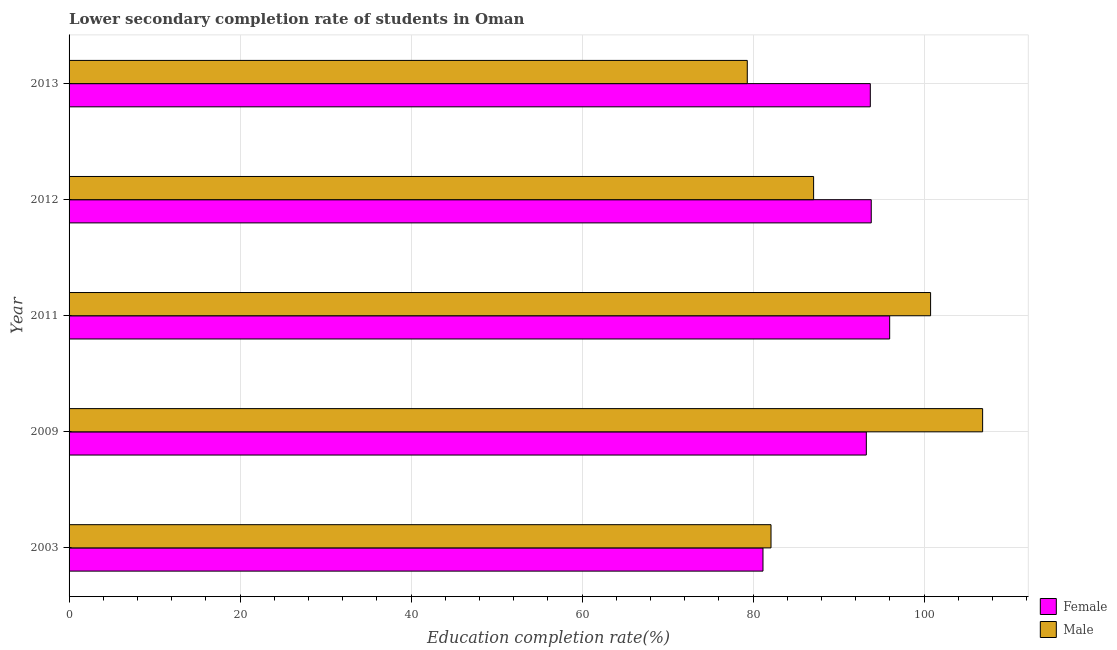How many different coloured bars are there?
Offer a very short reply. 2. How many groups of bars are there?
Your response must be concise. 5. How many bars are there on the 5th tick from the bottom?
Your response must be concise. 2. What is the education completion rate of male students in 2012?
Give a very brief answer. 87.08. Across all years, what is the maximum education completion rate of female students?
Ensure brevity in your answer.  95.97. Across all years, what is the minimum education completion rate of female students?
Your answer should be compact. 81.16. In which year was the education completion rate of male students maximum?
Give a very brief answer. 2009. What is the total education completion rate of male students in the graph?
Offer a very short reply. 456.1. What is the difference between the education completion rate of female students in 2003 and that in 2012?
Offer a terse response. -12.66. What is the difference between the education completion rate of male students in 2009 and the education completion rate of female students in 2003?
Give a very brief answer. 25.69. What is the average education completion rate of female students per year?
Keep it short and to the point. 91.58. In the year 2013, what is the difference between the education completion rate of female students and education completion rate of male students?
Offer a very short reply. 14.39. What is the ratio of the education completion rate of female students in 2011 to that in 2013?
Ensure brevity in your answer.  1.02. What is the difference between the highest and the second highest education completion rate of male students?
Make the answer very short. 6.08. What is the difference between the highest and the lowest education completion rate of male students?
Ensure brevity in your answer.  27.52. In how many years, is the education completion rate of female students greater than the average education completion rate of female students taken over all years?
Your answer should be very brief. 4. What does the 1st bar from the top in 2012 represents?
Your response must be concise. Male. How many bars are there?
Provide a short and direct response. 10. How many years are there in the graph?
Make the answer very short. 5. Does the graph contain grids?
Your answer should be compact. Yes. Where does the legend appear in the graph?
Offer a very short reply. Bottom right. What is the title of the graph?
Ensure brevity in your answer.  Lower secondary completion rate of students in Oman. What is the label or title of the X-axis?
Your response must be concise. Education completion rate(%). What is the Education completion rate(%) of Female in 2003?
Give a very brief answer. 81.16. What is the Education completion rate(%) of Male in 2003?
Give a very brief answer. 82.1. What is the Education completion rate(%) of Female in 2009?
Your answer should be very brief. 93.24. What is the Education completion rate(%) of Male in 2009?
Keep it short and to the point. 106.85. What is the Education completion rate(%) of Female in 2011?
Offer a terse response. 95.97. What is the Education completion rate(%) of Male in 2011?
Your answer should be very brief. 100.76. What is the Education completion rate(%) of Female in 2012?
Offer a terse response. 93.82. What is the Education completion rate(%) in Male in 2012?
Your answer should be very brief. 87.08. What is the Education completion rate(%) of Female in 2013?
Your response must be concise. 93.71. What is the Education completion rate(%) of Male in 2013?
Offer a very short reply. 79.32. Across all years, what is the maximum Education completion rate(%) in Female?
Make the answer very short. 95.97. Across all years, what is the maximum Education completion rate(%) of Male?
Your response must be concise. 106.85. Across all years, what is the minimum Education completion rate(%) of Female?
Offer a terse response. 81.16. Across all years, what is the minimum Education completion rate(%) of Male?
Give a very brief answer. 79.32. What is the total Education completion rate(%) of Female in the graph?
Your response must be concise. 457.9. What is the total Education completion rate(%) of Male in the graph?
Provide a succinct answer. 456.1. What is the difference between the Education completion rate(%) in Female in 2003 and that in 2009?
Provide a succinct answer. -12.09. What is the difference between the Education completion rate(%) in Male in 2003 and that in 2009?
Ensure brevity in your answer.  -24.75. What is the difference between the Education completion rate(%) in Female in 2003 and that in 2011?
Offer a very short reply. -14.82. What is the difference between the Education completion rate(%) in Male in 2003 and that in 2011?
Your answer should be very brief. -18.66. What is the difference between the Education completion rate(%) in Female in 2003 and that in 2012?
Provide a short and direct response. -12.66. What is the difference between the Education completion rate(%) of Male in 2003 and that in 2012?
Your answer should be very brief. -4.98. What is the difference between the Education completion rate(%) of Female in 2003 and that in 2013?
Offer a terse response. -12.55. What is the difference between the Education completion rate(%) of Male in 2003 and that in 2013?
Provide a short and direct response. 2.77. What is the difference between the Education completion rate(%) of Female in 2009 and that in 2011?
Provide a short and direct response. -2.73. What is the difference between the Education completion rate(%) in Male in 2009 and that in 2011?
Your answer should be very brief. 6.09. What is the difference between the Education completion rate(%) in Female in 2009 and that in 2012?
Provide a short and direct response. -0.57. What is the difference between the Education completion rate(%) of Male in 2009 and that in 2012?
Provide a succinct answer. 19.77. What is the difference between the Education completion rate(%) of Female in 2009 and that in 2013?
Offer a very short reply. -0.46. What is the difference between the Education completion rate(%) in Male in 2009 and that in 2013?
Offer a very short reply. 27.52. What is the difference between the Education completion rate(%) of Female in 2011 and that in 2012?
Give a very brief answer. 2.16. What is the difference between the Education completion rate(%) in Male in 2011 and that in 2012?
Offer a terse response. 13.68. What is the difference between the Education completion rate(%) in Female in 2011 and that in 2013?
Make the answer very short. 2.27. What is the difference between the Education completion rate(%) in Male in 2011 and that in 2013?
Offer a very short reply. 21.44. What is the difference between the Education completion rate(%) in Female in 2012 and that in 2013?
Offer a very short reply. 0.11. What is the difference between the Education completion rate(%) of Male in 2012 and that in 2013?
Provide a succinct answer. 7.76. What is the difference between the Education completion rate(%) of Female in 2003 and the Education completion rate(%) of Male in 2009?
Make the answer very short. -25.69. What is the difference between the Education completion rate(%) of Female in 2003 and the Education completion rate(%) of Male in 2011?
Provide a short and direct response. -19.6. What is the difference between the Education completion rate(%) in Female in 2003 and the Education completion rate(%) in Male in 2012?
Your answer should be compact. -5.92. What is the difference between the Education completion rate(%) in Female in 2003 and the Education completion rate(%) in Male in 2013?
Keep it short and to the point. 1.84. What is the difference between the Education completion rate(%) in Female in 2009 and the Education completion rate(%) in Male in 2011?
Your response must be concise. -7.52. What is the difference between the Education completion rate(%) in Female in 2009 and the Education completion rate(%) in Male in 2012?
Ensure brevity in your answer.  6.17. What is the difference between the Education completion rate(%) in Female in 2009 and the Education completion rate(%) in Male in 2013?
Your answer should be very brief. 13.92. What is the difference between the Education completion rate(%) of Female in 2011 and the Education completion rate(%) of Male in 2012?
Provide a succinct answer. 8.9. What is the difference between the Education completion rate(%) in Female in 2011 and the Education completion rate(%) in Male in 2013?
Ensure brevity in your answer.  16.65. What is the difference between the Education completion rate(%) in Female in 2012 and the Education completion rate(%) in Male in 2013?
Your answer should be compact. 14.5. What is the average Education completion rate(%) in Female per year?
Your answer should be compact. 91.58. What is the average Education completion rate(%) in Male per year?
Make the answer very short. 91.22. In the year 2003, what is the difference between the Education completion rate(%) of Female and Education completion rate(%) of Male?
Your answer should be very brief. -0.94. In the year 2009, what is the difference between the Education completion rate(%) of Female and Education completion rate(%) of Male?
Give a very brief answer. -13.6. In the year 2011, what is the difference between the Education completion rate(%) in Female and Education completion rate(%) in Male?
Provide a short and direct response. -4.79. In the year 2012, what is the difference between the Education completion rate(%) in Female and Education completion rate(%) in Male?
Give a very brief answer. 6.74. In the year 2013, what is the difference between the Education completion rate(%) in Female and Education completion rate(%) in Male?
Your answer should be very brief. 14.39. What is the ratio of the Education completion rate(%) of Female in 2003 to that in 2009?
Give a very brief answer. 0.87. What is the ratio of the Education completion rate(%) of Male in 2003 to that in 2009?
Your response must be concise. 0.77. What is the ratio of the Education completion rate(%) of Female in 2003 to that in 2011?
Keep it short and to the point. 0.85. What is the ratio of the Education completion rate(%) of Male in 2003 to that in 2011?
Your answer should be compact. 0.81. What is the ratio of the Education completion rate(%) of Female in 2003 to that in 2012?
Give a very brief answer. 0.86. What is the ratio of the Education completion rate(%) in Male in 2003 to that in 2012?
Give a very brief answer. 0.94. What is the ratio of the Education completion rate(%) in Female in 2003 to that in 2013?
Give a very brief answer. 0.87. What is the ratio of the Education completion rate(%) of Male in 2003 to that in 2013?
Offer a terse response. 1.03. What is the ratio of the Education completion rate(%) of Female in 2009 to that in 2011?
Your answer should be compact. 0.97. What is the ratio of the Education completion rate(%) in Male in 2009 to that in 2011?
Your answer should be very brief. 1.06. What is the ratio of the Education completion rate(%) of Male in 2009 to that in 2012?
Offer a terse response. 1.23. What is the ratio of the Education completion rate(%) in Male in 2009 to that in 2013?
Make the answer very short. 1.35. What is the ratio of the Education completion rate(%) of Male in 2011 to that in 2012?
Make the answer very short. 1.16. What is the ratio of the Education completion rate(%) in Female in 2011 to that in 2013?
Ensure brevity in your answer.  1.02. What is the ratio of the Education completion rate(%) of Male in 2011 to that in 2013?
Your answer should be compact. 1.27. What is the ratio of the Education completion rate(%) of Male in 2012 to that in 2013?
Your answer should be compact. 1.1. What is the difference between the highest and the second highest Education completion rate(%) of Female?
Offer a very short reply. 2.16. What is the difference between the highest and the second highest Education completion rate(%) of Male?
Make the answer very short. 6.09. What is the difference between the highest and the lowest Education completion rate(%) in Female?
Keep it short and to the point. 14.82. What is the difference between the highest and the lowest Education completion rate(%) in Male?
Provide a short and direct response. 27.52. 